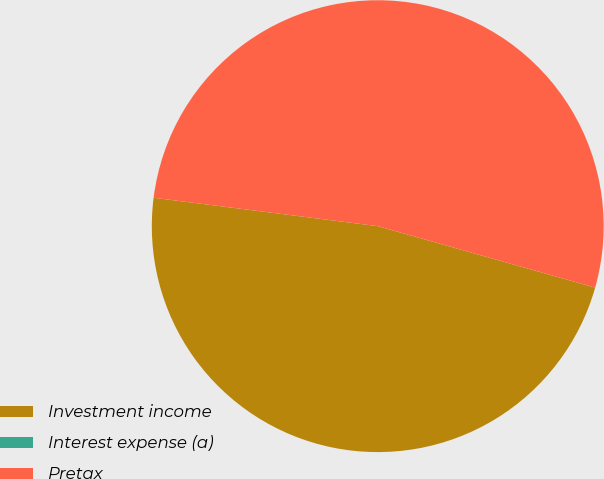Convert chart to OTSL. <chart><loc_0><loc_0><loc_500><loc_500><pie_chart><fcel>Investment income<fcel>Interest expense (a)<fcel>Pretax<nl><fcel>47.62%<fcel>0.0%<fcel>52.38%<nl></chart> 